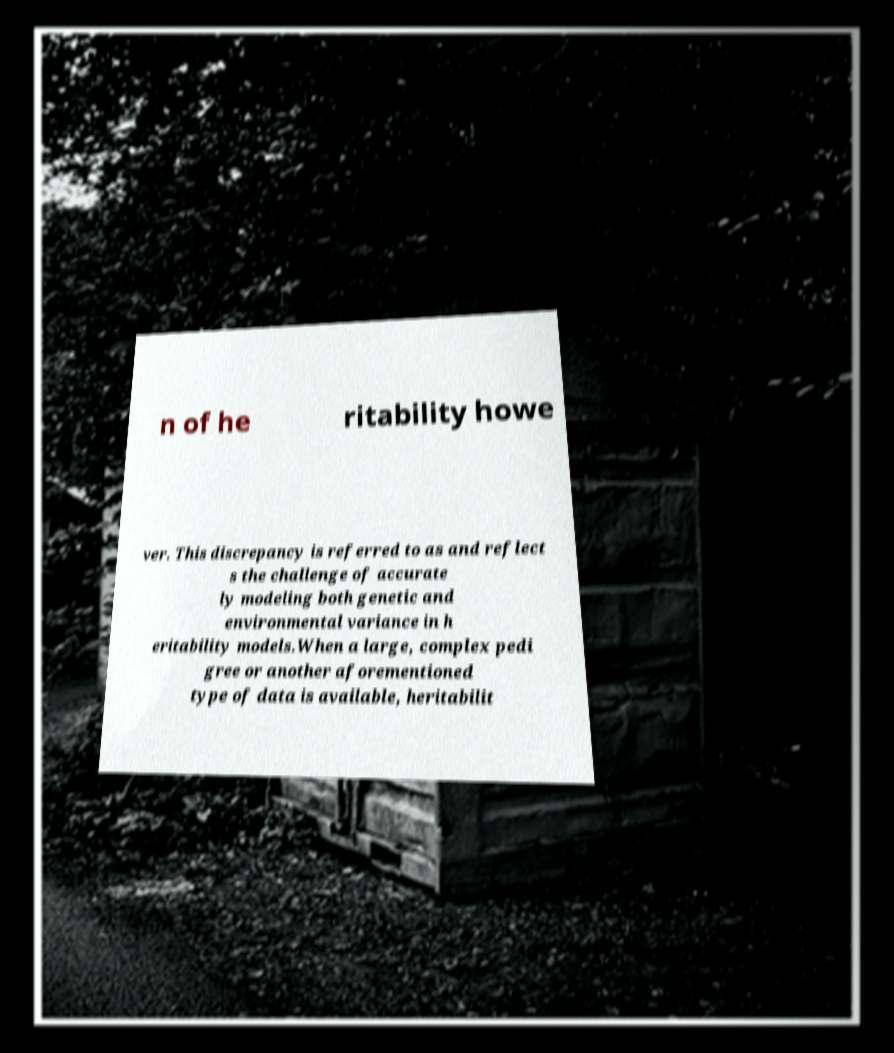Can you read and provide the text displayed in the image?This photo seems to have some interesting text. Can you extract and type it out for me? n of he ritability howe ver. This discrepancy is referred to as and reflect s the challenge of accurate ly modeling both genetic and environmental variance in h eritability models.When a large, complex pedi gree or another aforementioned type of data is available, heritabilit 